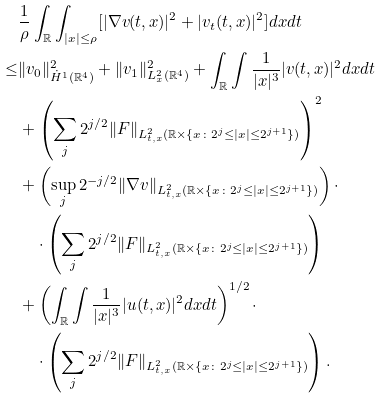<formula> <loc_0><loc_0><loc_500><loc_500>& \frac { 1 } { \rho } \int _ { \mathbb { R } } \int _ { | x | \leq \rho } [ | \nabla v ( t , x ) | ^ { 2 } + | v _ { t } ( t , x ) | ^ { 2 } ] d x d t \\ \leq & \| v _ { 0 } \| _ { \dot { H } ^ { 1 } ( \mathbb { R } ^ { 4 } ) } ^ { 2 } + \| v _ { 1 } \| _ { L _ { x } ^ { 2 } ( \mathbb { R } ^ { 4 } ) } ^ { 2 } + \int _ { \mathbb { R } } \int \frac { 1 } { | x | ^ { 3 } } | v ( t , x ) | ^ { 2 } d x d t \\ & + \left ( \sum _ { j } 2 ^ { j / 2 } \| F \| _ { L _ { t , x } ^ { 2 } ( \mathbb { R } \times \{ x \colon 2 ^ { j } \leq | x | \leq 2 ^ { j + 1 } \} ) } \right ) ^ { 2 } \\ & + \left ( \sup _ { j } 2 ^ { - j / 2 } \| \nabla v \| _ { L _ { t , x } ^ { 2 } ( \mathbb { R } \times \{ x \colon 2 ^ { j } \leq | x | \leq 2 ^ { j + 1 } \} ) } \right ) \cdot \\ & \quad \cdot \left ( \sum _ { j } 2 ^ { j / 2 } \| F \| _ { L _ { t , x } ^ { 2 } ( \mathbb { R } \times \{ x \colon 2 ^ { j } \leq | x | \leq 2 ^ { j + 1 } \} ) } \right ) \\ & + \left ( \int _ { \mathbb { R } } \int \frac { 1 } { | x | ^ { 3 } } | u ( t , x ) | ^ { 2 } d x d t \right ) ^ { 1 / 2 } \cdot \\ & \quad \cdot \left ( \sum _ { j } 2 ^ { j / 2 } \| F \| _ { L _ { t , x } ^ { 2 } ( \mathbb { R } \times \{ x \colon 2 ^ { j } \leq | x | \leq 2 ^ { j + 1 } \} ) } \right ) .</formula> 